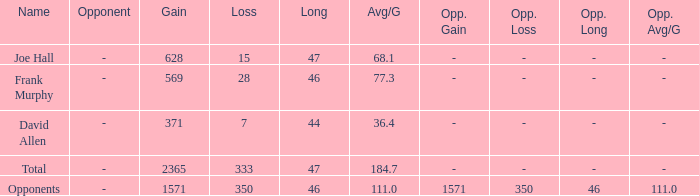Which Avg/G is the lowest one that has a Long smaller than 47, and a Name of frank murphy, and a Gain smaller than 569? None. 